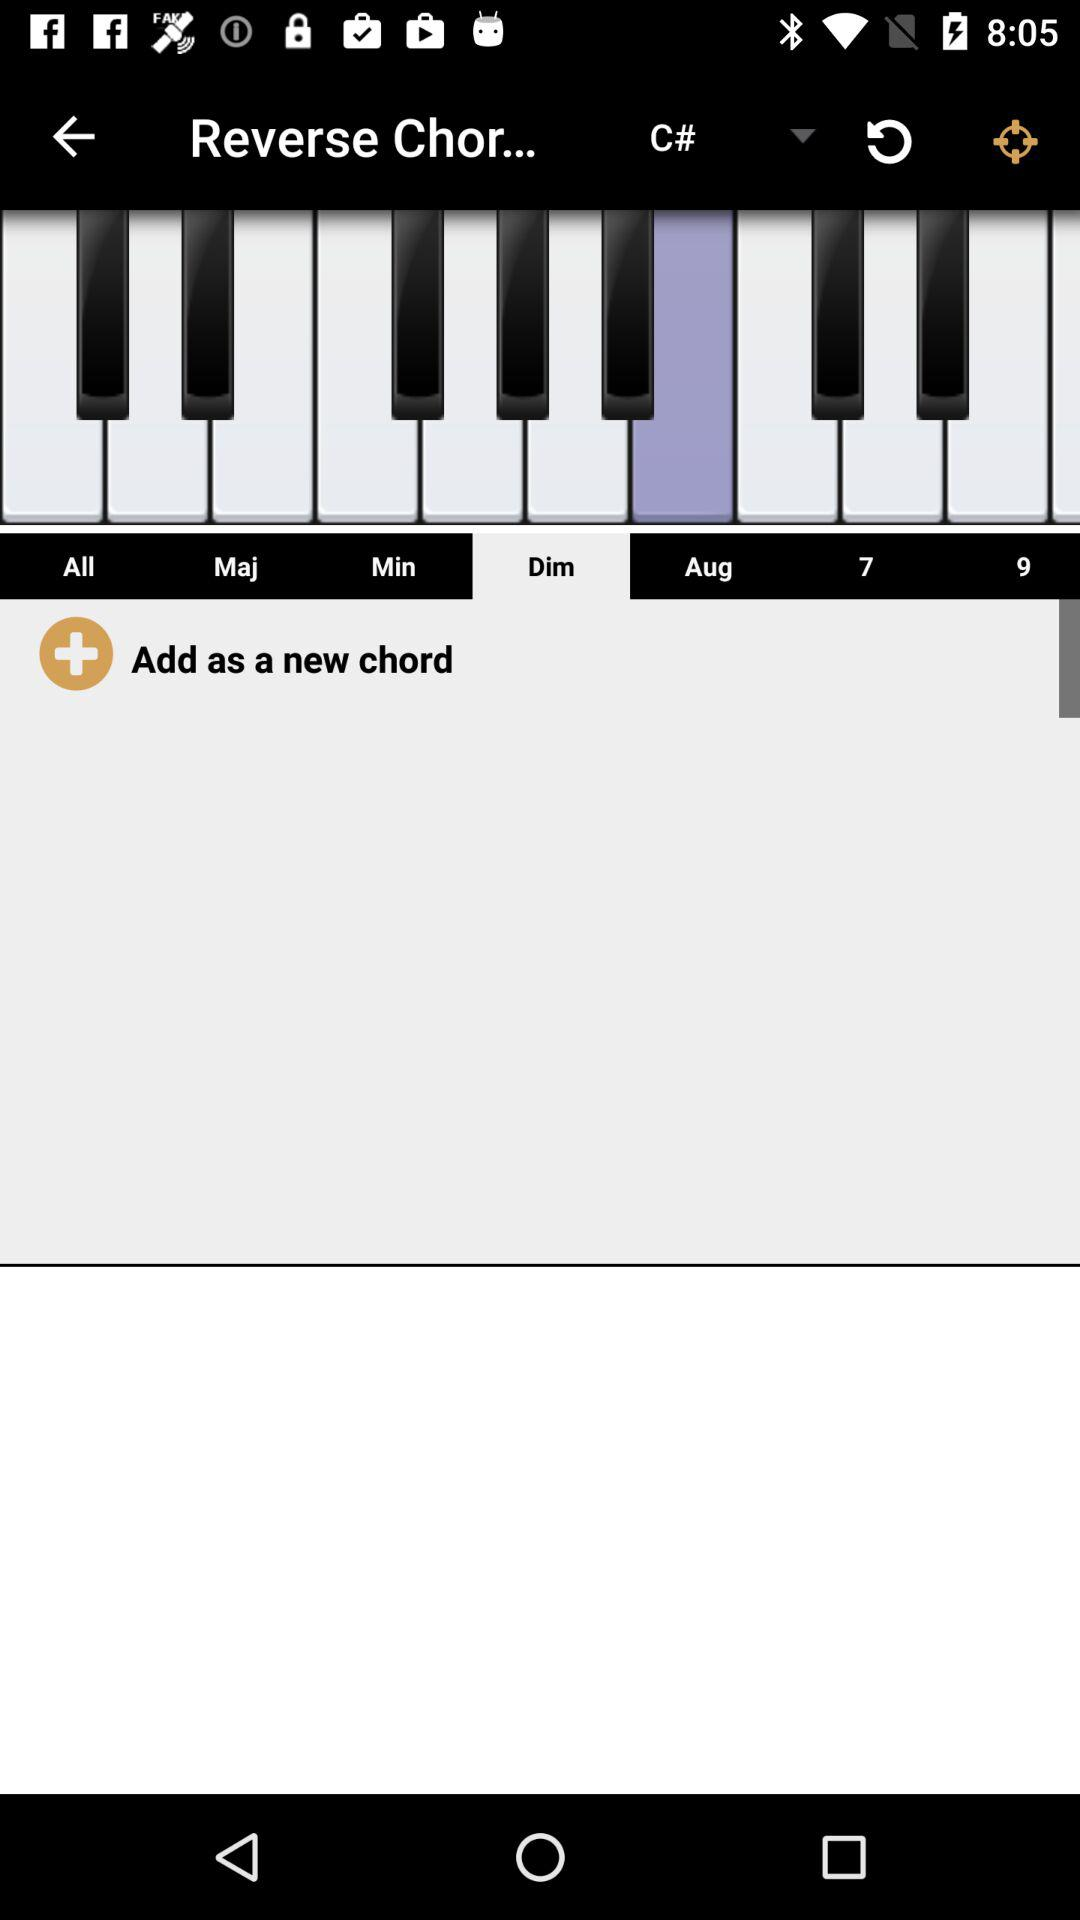Which tab is selected? The selected tab is "Dim". 